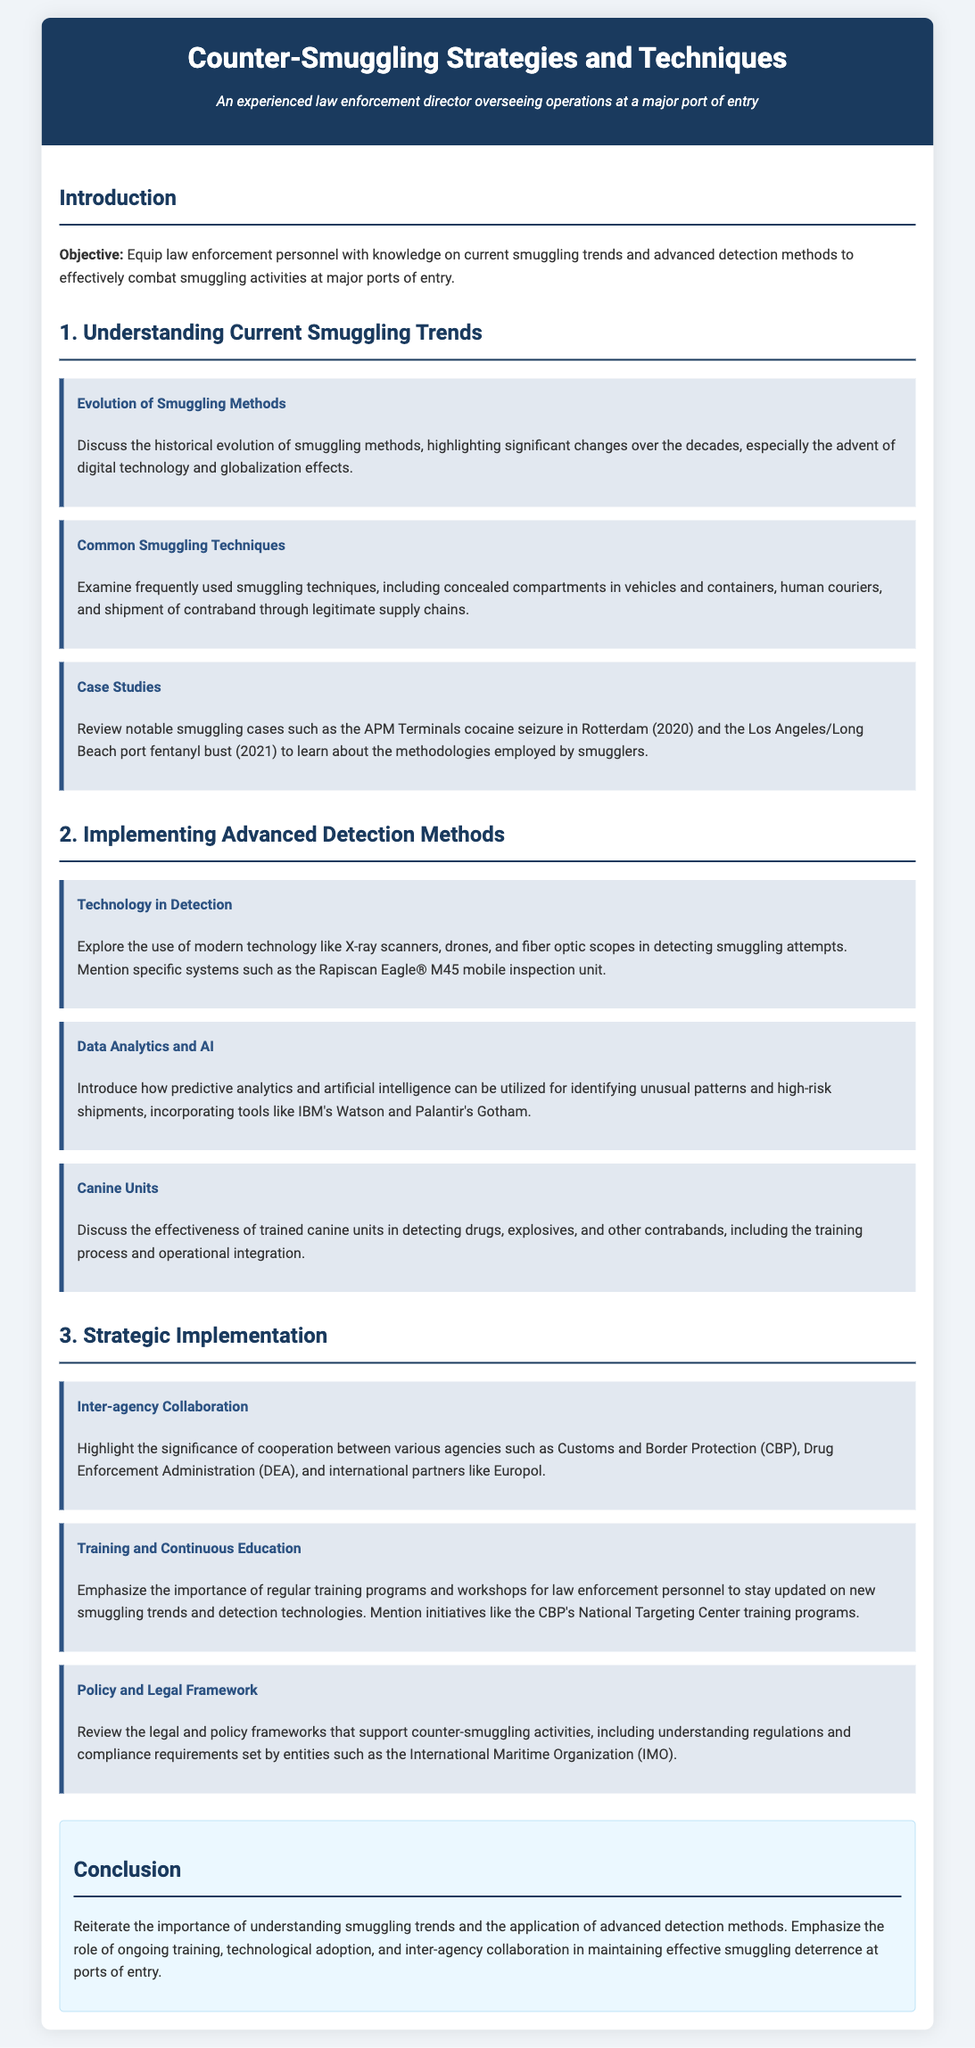What is the main objective of the lesson plan? The objective outlines that the lesson aims to equip law enforcement personnel with knowledge on current smuggling trends and advanced detection methods.
Answer: Equip law enforcement personnel with knowledge on current smuggling trends and advanced detection methods Which case study is mentioned regarding cocaine seizure? The document references the APM Terminals cocaine seizure in 2020 as a notable case study.
Answer: APM Terminals cocaine seizure in Rotterdam (2020) What technology is discussed for detecting smuggling attempts? The lesson plan lists X-ray scanners, drones, and fiber optic scopes as technologies used in detection.
Answer: X-ray scanners, drones, and fiber optic scopes Who should collaborate for effective counter-smuggling strategies? Inter-agency collaboration highlights the significance of cooperation between various agencies such as Customs and Border Protection and Drug Enforcement Administration.
Answer: Customs and Border Protection and Drug Enforcement Administration What is emphasized for law enforcement personnel’s effectiveness? The document stresses the importance of regular training programs and workshops for law enforcement personnel to stay updated on new smuggling trends.
Answer: Regular training programs and workshops 